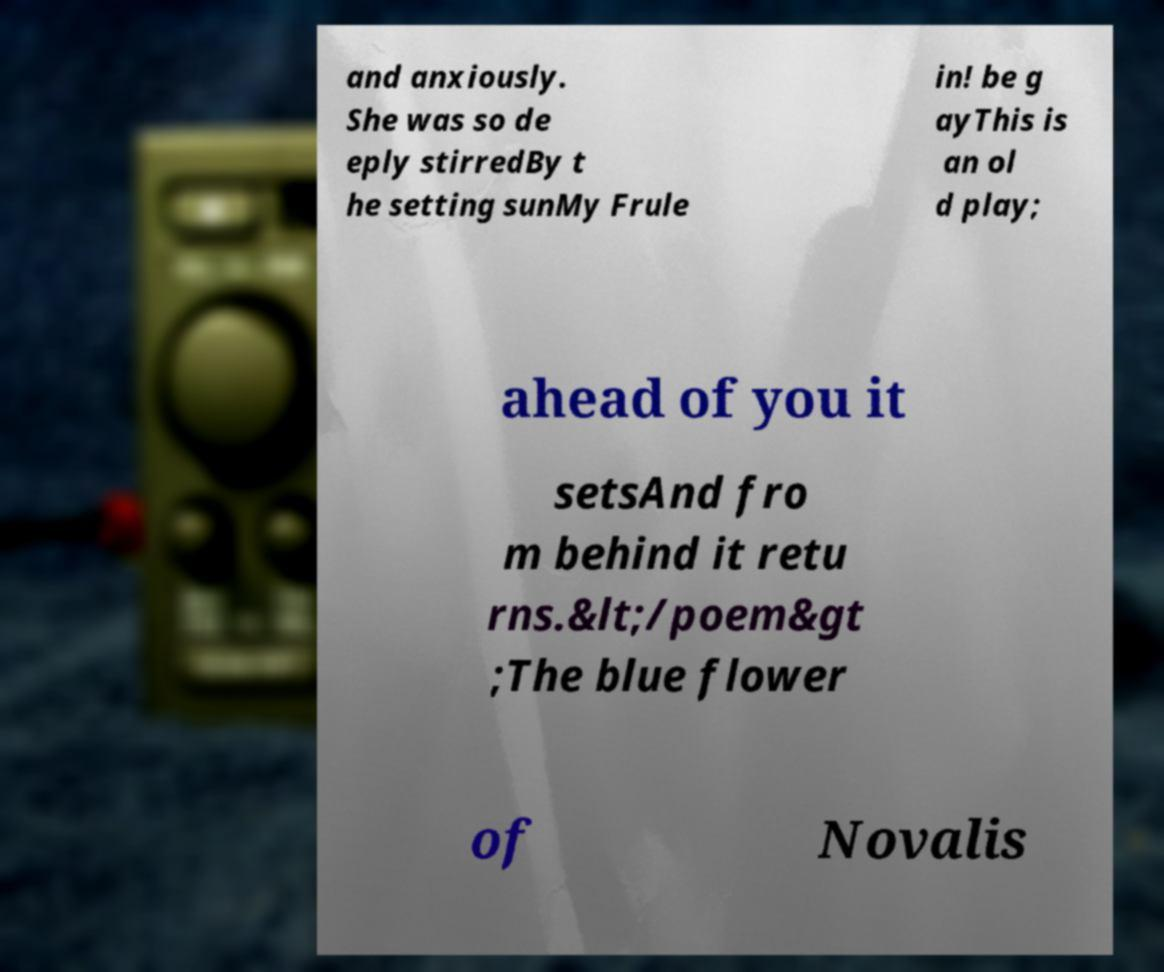Please read and relay the text visible in this image. What does it say? and anxiously. She was so de eply stirredBy t he setting sunMy Frule in! be g ayThis is an ol d play; ahead of you it setsAnd fro m behind it retu rns.&lt;/poem&gt ;The blue flower of Novalis 